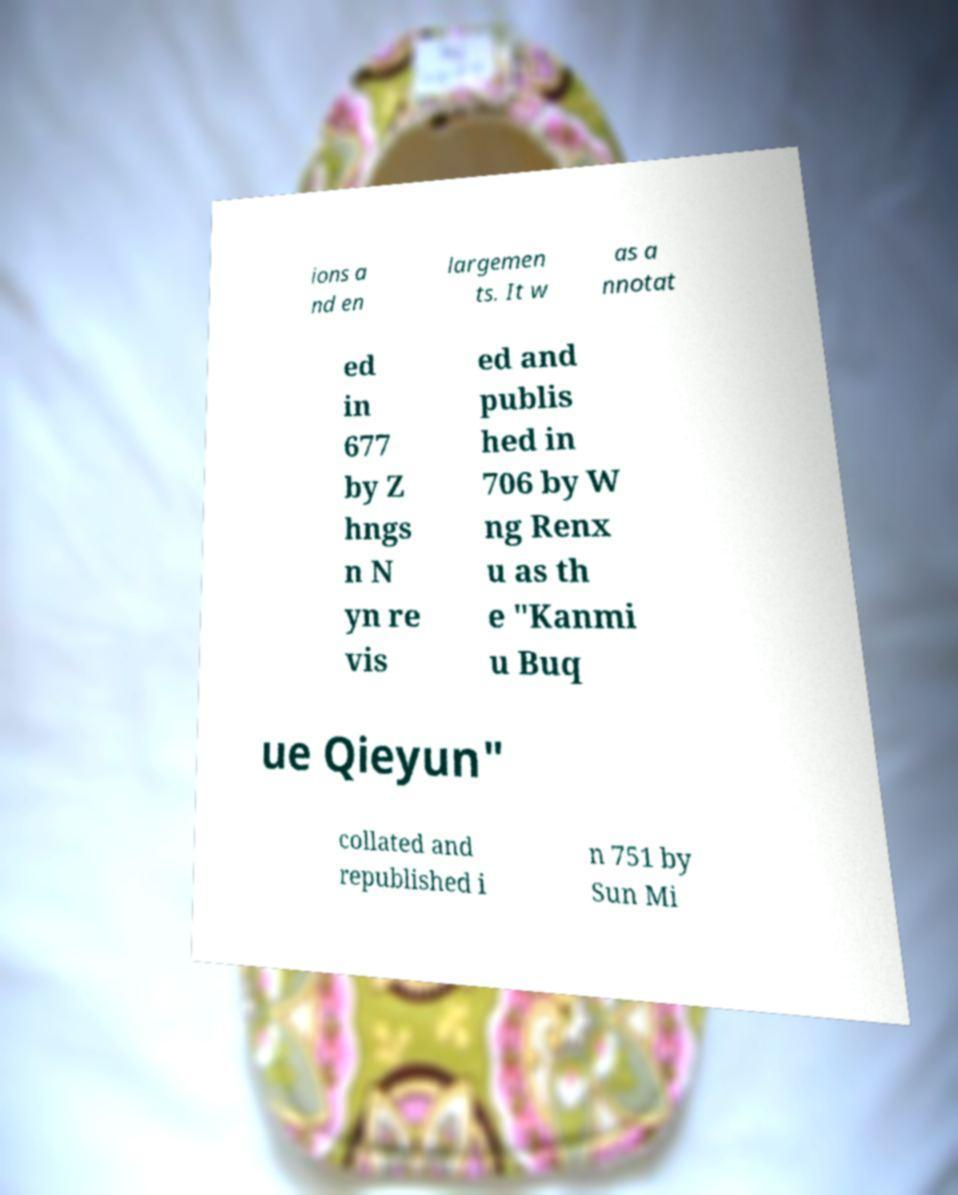Could you extract and type out the text from this image? ions a nd en largemen ts. It w as a nnotat ed in 677 by Z hngs n N yn re vis ed and publis hed in 706 by W ng Renx u as th e "Kanmi u Buq ue Qieyun" collated and republished i n 751 by Sun Mi 